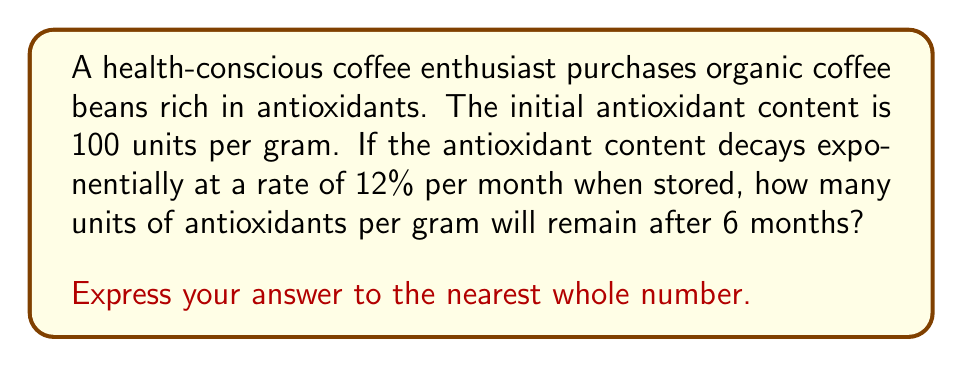Show me your answer to this math problem. Let's approach this step-by-step using the exponential decay formula:

1) The exponential decay formula is:
   $A(t) = A_0 \cdot (1-r)^t$

   Where:
   $A(t)$ is the amount at time $t$
   $A_0$ is the initial amount
   $r$ is the decay rate
   $t$ is the time

2) We know:
   $A_0 = 100$ units
   $r = 12\% = 0.12$
   $t = 6$ months

3) Plugging these values into the formula:
   $A(6) = 100 \cdot (1-0.12)^6$

4) Simplify:
   $A(6) = 100 \cdot (0.88)^6$

5) Calculate:
   $A(6) = 100 \cdot 0.4556$
   $A(6) = 45.56$

6) Rounding to the nearest whole number:
   $A(6) \approx 46$ units

Therefore, after 6 months, approximately 46 units of antioxidants per gram will remain in the stored coffee beans.
Answer: 46 units 